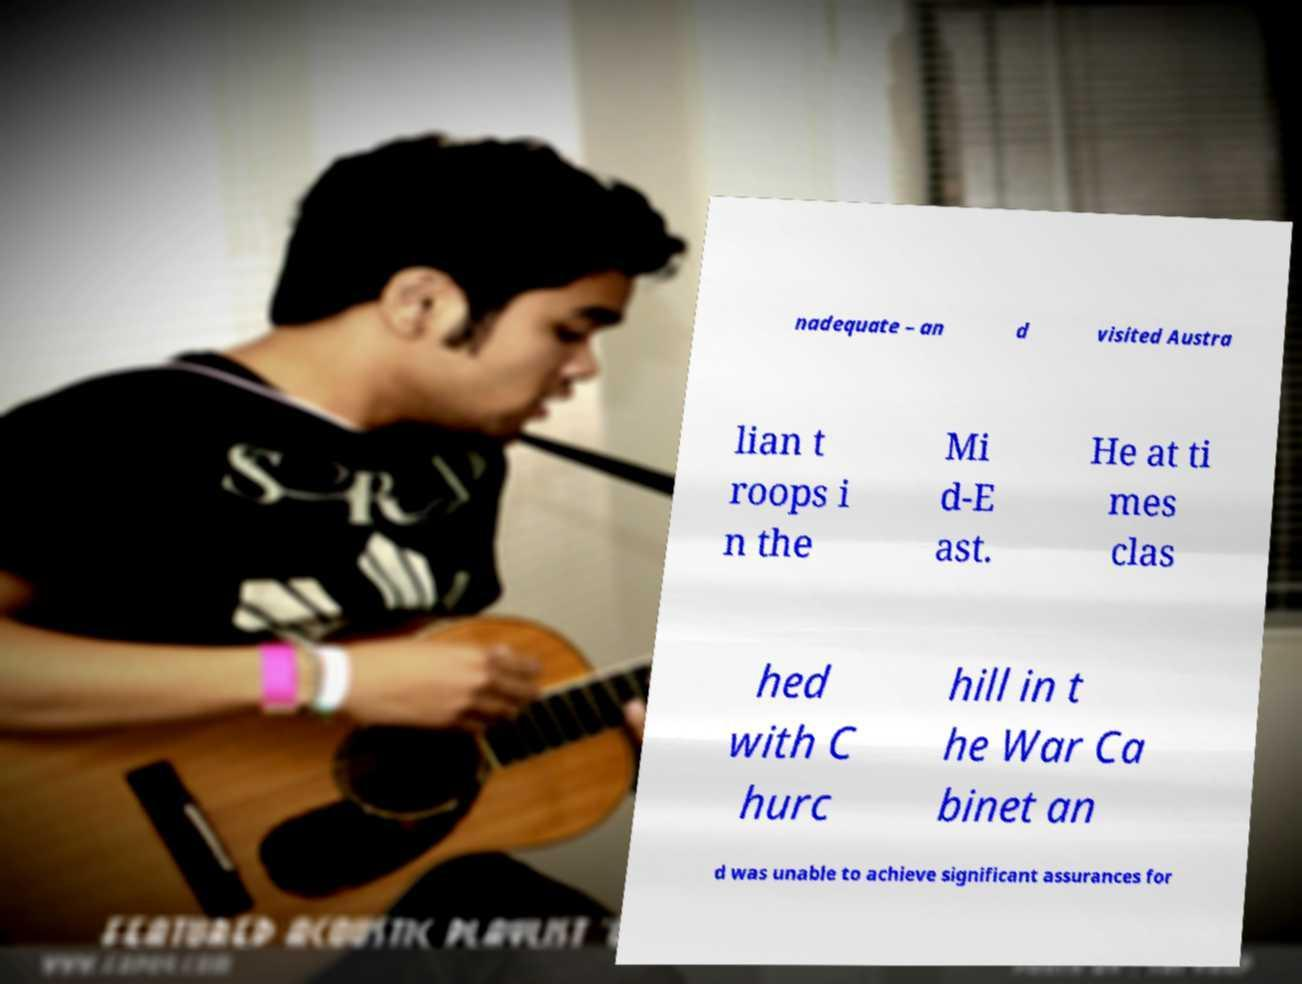Could you assist in decoding the text presented in this image and type it out clearly? nadequate – an d visited Austra lian t roops i n the Mi d-E ast. He at ti mes clas hed with C hurc hill in t he War Ca binet an d was unable to achieve significant assurances for 